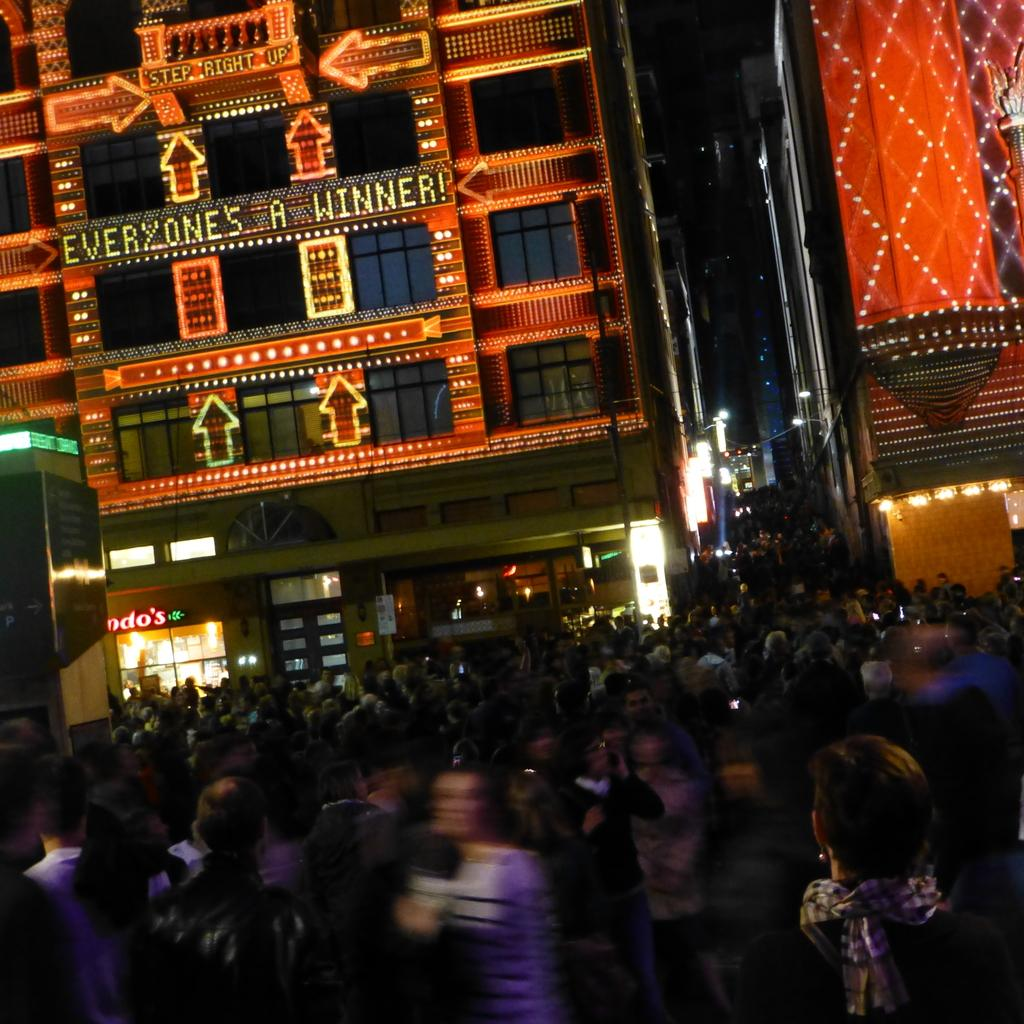What time of day was the image taken? The image was taken during night time. What can be seen in the image besides the buildings? There are lights visible in the image. What is the weather condition in the image? The presence of lightning suggests a stormy weather condition. How many people are visible at the bottom of the image? There are many people at the bottom of the image. What type of heart-shaped object can be seen in the image? There is no heart-shaped object present in the image. What subject is being taught in the image? There is no teaching or educational activity depicted in the image. 